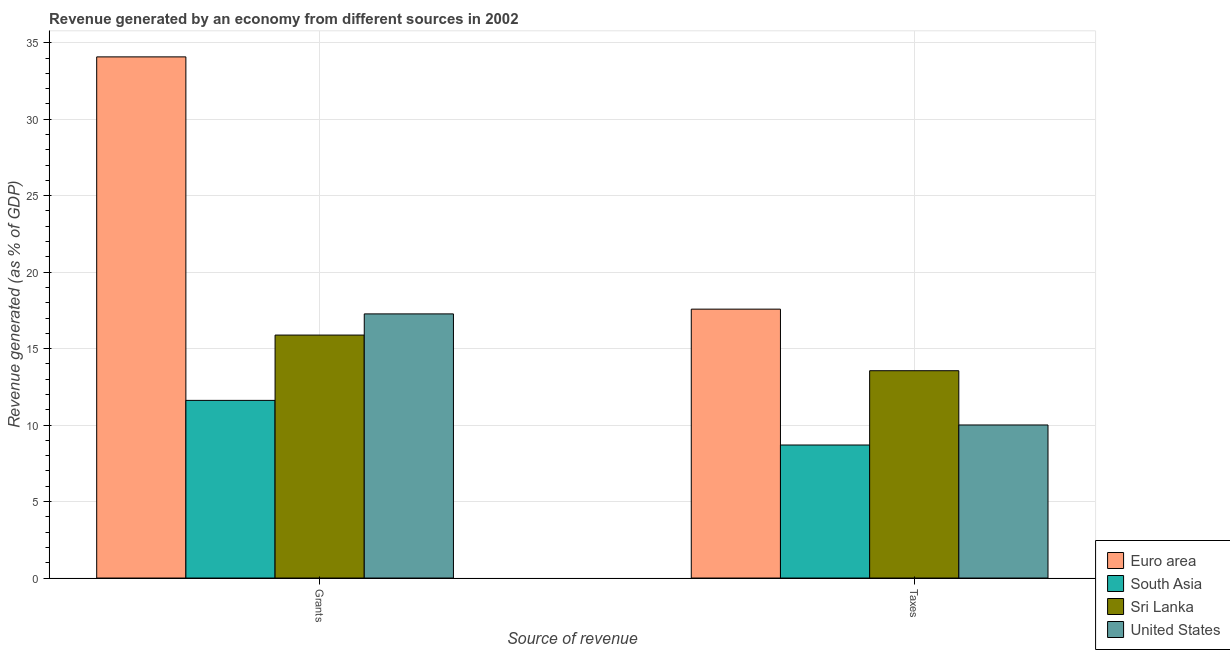How many different coloured bars are there?
Give a very brief answer. 4. Are the number of bars per tick equal to the number of legend labels?
Keep it short and to the point. Yes. Are the number of bars on each tick of the X-axis equal?
Your answer should be very brief. Yes. What is the label of the 2nd group of bars from the left?
Make the answer very short. Taxes. What is the revenue generated by grants in Euro area?
Make the answer very short. 34.08. Across all countries, what is the maximum revenue generated by taxes?
Your response must be concise. 17.58. Across all countries, what is the minimum revenue generated by taxes?
Your answer should be compact. 8.7. In which country was the revenue generated by taxes maximum?
Keep it short and to the point. Euro area. What is the total revenue generated by taxes in the graph?
Offer a very short reply. 49.85. What is the difference between the revenue generated by taxes in United States and that in Sri Lanka?
Offer a very short reply. -3.55. What is the difference between the revenue generated by taxes in United States and the revenue generated by grants in Sri Lanka?
Offer a very short reply. -5.88. What is the average revenue generated by grants per country?
Make the answer very short. 19.71. What is the difference between the revenue generated by taxes and revenue generated by grants in Sri Lanka?
Your answer should be compact. -2.33. What is the ratio of the revenue generated by grants in Sri Lanka to that in Euro area?
Your response must be concise. 0.47. Is the revenue generated by taxes in South Asia less than that in Euro area?
Provide a short and direct response. Yes. What does the 2nd bar from the left in Grants represents?
Offer a very short reply. South Asia. What does the 4th bar from the right in Taxes represents?
Ensure brevity in your answer.  Euro area. How many countries are there in the graph?
Your answer should be compact. 4. Are the values on the major ticks of Y-axis written in scientific E-notation?
Ensure brevity in your answer.  No. How are the legend labels stacked?
Keep it short and to the point. Vertical. What is the title of the graph?
Your answer should be compact. Revenue generated by an economy from different sources in 2002. Does "West Bank and Gaza" appear as one of the legend labels in the graph?
Your response must be concise. No. What is the label or title of the X-axis?
Give a very brief answer. Source of revenue. What is the label or title of the Y-axis?
Provide a succinct answer. Revenue generated (as % of GDP). What is the Revenue generated (as % of GDP) of Euro area in Grants?
Your response must be concise. 34.08. What is the Revenue generated (as % of GDP) of South Asia in Grants?
Give a very brief answer. 11.62. What is the Revenue generated (as % of GDP) in Sri Lanka in Grants?
Keep it short and to the point. 15.89. What is the Revenue generated (as % of GDP) of United States in Grants?
Ensure brevity in your answer.  17.27. What is the Revenue generated (as % of GDP) of Euro area in Taxes?
Offer a terse response. 17.58. What is the Revenue generated (as % of GDP) of South Asia in Taxes?
Your response must be concise. 8.7. What is the Revenue generated (as % of GDP) in Sri Lanka in Taxes?
Give a very brief answer. 13.56. What is the Revenue generated (as % of GDP) in United States in Taxes?
Provide a succinct answer. 10.01. Across all Source of revenue, what is the maximum Revenue generated (as % of GDP) of Euro area?
Offer a very short reply. 34.08. Across all Source of revenue, what is the maximum Revenue generated (as % of GDP) of South Asia?
Provide a succinct answer. 11.62. Across all Source of revenue, what is the maximum Revenue generated (as % of GDP) of Sri Lanka?
Offer a terse response. 15.89. Across all Source of revenue, what is the maximum Revenue generated (as % of GDP) of United States?
Make the answer very short. 17.27. Across all Source of revenue, what is the minimum Revenue generated (as % of GDP) of Euro area?
Keep it short and to the point. 17.58. Across all Source of revenue, what is the minimum Revenue generated (as % of GDP) of South Asia?
Offer a terse response. 8.7. Across all Source of revenue, what is the minimum Revenue generated (as % of GDP) in Sri Lanka?
Offer a very short reply. 13.56. Across all Source of revenue, what is the minimum Revenue generated (as % of GDP) of United States?
Provide a succinct answer. 10.01. What is the total Revenue generated (as % of GDP) in Euro area in the graph?
Your response must be concise. 51.66. What is the total Revenue generated (as % of GDP) in South Asia in the graph?
Keep it short and to the point. 20.31. What is the total Revenue generated (as % of GDP) in Sri Lanka in the graph?
Give a very brief answer. 29.44. What is the total Revenue generated (as % of GDP) in United States in the graph?
Keep it short and to the point. 27.28. What is the difference between the Revenue generated (as % of GDP) of Euro area in Grants and that in Taxes?
Your response must be concise. 16.49. What is the difference between the Revenue generated (as % of GDP) of South Asia in Grants and that in Taxes?
Provide a short and direct response. 2.92. What is the difference between the Revenue generated (as % of GDP) of Sri Lanka in Grants and that in Taxes?
Your answer should be compact. 2.33. What is the difference between the Revenue generated (as % of GDP) of United States in Grants and that in Taxes?
Give a very brief answer. 7.26. What is the difference between the Revenue generated (as % of GDP) in Euro area in Grants and the Revenue generated (as % of GDP) in South Asia in Taxes?
Your answer should be compact. 25.38. What is the difference between the Revenue generated (as % of GDP) of Euro area in Grants and the Revenue generated (as % of GDP) of Sri Lanka in Taxes?
Keep it short and to the point. 20.52. What is the difference between the Revenue generated (as % of GDP) in Euro area in Grants and the Revenue generated (as % of GDP) in United States in Taxes?
Keep it short and to the point. 24.07. What is the difference between the Revenue generated (as % of GDP) in South Asia in Grants and the Revenue generated (as % of GDP) in Sri Lanka in Taxes?
Offer a terse response. -1.94. What is the difference between the Revenue generated (as % of GDP) of South Asia in Grants and the Revenue generated (as % of GDP) of United States in Taxes?
Make the answer very short. 1.61. What is the difference between the Revenue generated (as % of GDP) in Sri Lanka in Grants and the Revenue generated (as % of GDP) in United States in Taxes?
Your answer should be very brief. 5.88. What is the average Revenue generated (as % of GDP) of Euro area per Source of revenue?
Keep it short and to the point. 25.83. What is the average Revenue generated (as % of GDP) of South Asia per Source of revenue?
Keep it short and to the point. 10.16. What is the average Revenue generated (as % of GDP) of Sri Lanka per Source of revenue?
Provide a succinct answer. 14.72. What is the average Revenue generated (as % of GDP) of United States per Source of revenue?
Provide a succinct answer. 13.64. What is the difference between the Revenue generated (as % of GDP) in Euro area and Revenue generated (as % of GDP) in South Asia in Grants?
Provide a succinct answer. 22.46. What is the difference between the Revenue generated (as % of GDP) in Euro area and Revenue generated (as % of GDP) in Sri Lanka in Grants?
Your answer should be very brief. 18.19. What is the difference between the Revenue generated (as % of GDP) of Euro area and Revenue generated (as % of GDP) of United States in Grants?
Your response must be concise. 16.81. What is the difference between the Revenue generated (as % of GDP) in South Asia and Revenue generated (as % of GDP) in Sri Lanka in Grants?
Provide a short and direct response. -4.27. What is the difference between the Revenue generated (as % of GDP) of South Asia and Revenue generated (as % of GDP) of United States in Grants?
Give a very brief answer. -5.66. What is the difference between the Revenue generated (as % of GDP) in Sri Lanka and Revenue generated (as % of GDP) in United States in Grants?
Give a very brief answer. -1.38. What is the difference between the Revenue generated (as % of GDP) in Euro area and Revenue generated (as % of GDP) in South Asia in Taxes?
Offer a very short reply. 8.88. What is the difference between the Revenue generated (as % of GDP) of Euro area and Revenue generated (as % of GDP) of Sri Lanka in Taxes?
Make the answer very short. 4.03. What is the difference between the Revenue generated (as % of GDP) in Euro area and Revenue generated (as % of GDP) in United States in Taxes?
Keep it short and to the point. 7.57. What is the difference between the Revenue generated (as % of GDP) in South Asia and Revenue generated (as % of GDP) in Sri Lanka in Taxes?
Keep it short and to the point. -4.86. What is the difference between the Revenue generated (as % of GDP) of South Asia and Revenue generated (as % of GDP) of United States in Taxes?
Keep it short and to the point. -1.31. What is the difference between the Revenue generated (as % of GDP) in Sri Lanka and Revenue generated (as % of GDP) in United States in Taxes?
Ensure brevity in your answer.  3.55. What is the ratio of the Revenue generated (as % of GDP) in Euro area in Grants to that in Taxes?
Give a very brief answer. 1.94. What is the ratio of the Revenue generated (as % of GDP) of South Asia in Grants to that in Taxes?
Your answer should be compact. 1.34. What is the ratio of the Revenue generated (as % of GDP) in Sri Lanka in Grants to that in Taxes?
Give a very brief answer. 1.17. What is the ratio of the Revenue generated (as % of GDP) in United States in Grants to that in Taxes?
Offer a terse response. 1.73. What is the difference between the highest and the second highest Revenue generated (as % of GDP) of Euro area?
Provide a succinct answer. 16.49. What is the difference between the highest and the second highest Revenue generated (as % of GDP) of South Asia?
Keep it short and to the point. 2.92. What is the difference between the highest and the second highest Revenue generated (as % of GDP) of Sri Lanka?
Provide a short and direct response. 2.33. What is the difference between the highest and the second highest Revenue generated (as % of GDP) in United States?
Your response must be concise. 7.26. What is the difference between the highest and the lowest Revenue generated (as % of GDP) in Euro area?
Make the answer very short. 16.49. What is the difference between the highest and the lowest Revenue generated (as % of GDP) of South Asia?
Offer a terse response. 2.92. What is the difference between the highest and the lowest Revenue generated (as % of GDP) of Sri Lanka?
Give a very brief answer. 2.33. What is the difference between the highest and the lowest Revenue generated (as % of GDP) of United States?
Your answer should be compact. 7.26. 